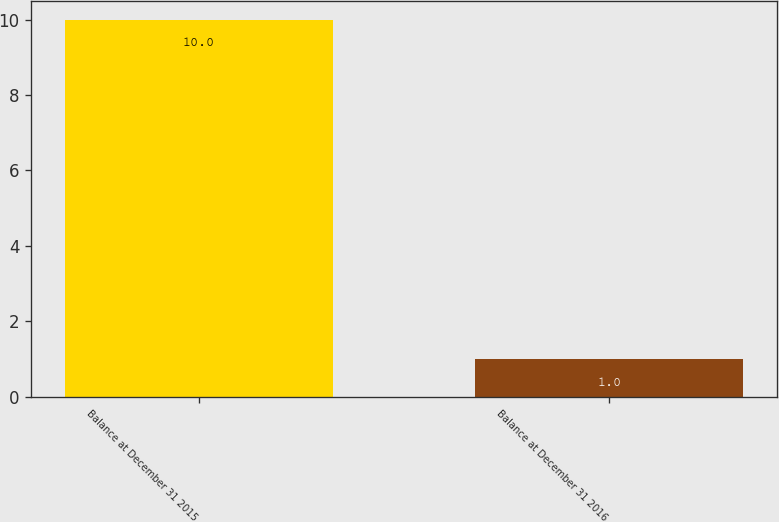Convert chart. <chart><loc_0><loc_0><loc_500><loc_500><bar_chart><fcel>Balance at December 31 2015<fcel>Balance at December 31 2016<nl><fcel>10<fcel>1<nl></chart> 